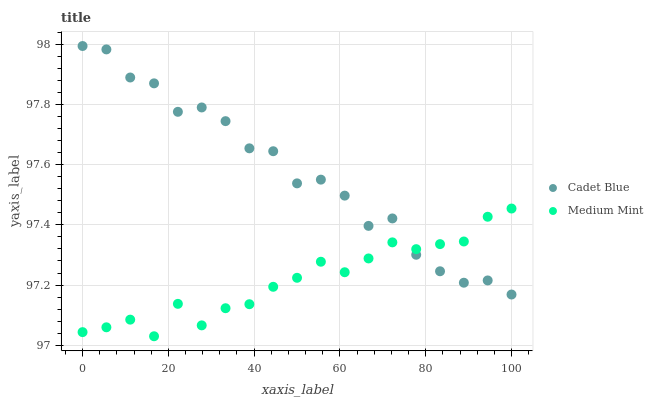Does Medium Mint have the minimum area under the curve?
Answer yes or no. Yes. Does Cadet Blue have the maximum area under the curve?
Answer yes or no. Yes. Does Cadet Blue have the minimum area under the curve?
Answer yes or no. No. Is Medium Mint the smoothest?
Answer yes or no. Yes. Is Cadet Blue the roughest?
Answer yes or no. Yes. Is Cadet Blue the smoothest?
Answer yes or no. No. Does Medium Mint have the lowest value?
Answer yes or no. Yes. Does Cadet Blue have the lowest value?
Answer yes or no. No. Does Cadet Blue have the highest value?
Answer yes or no. Yes. Does Medium Mint intersect Cadet Blue?
Answer yes or no. Yes. Is Medium Mint less than Cadet Blue?
Answer yes or no. No. Is Medium Mint greater than Cadet Blue?
Answer yes or no. No. 